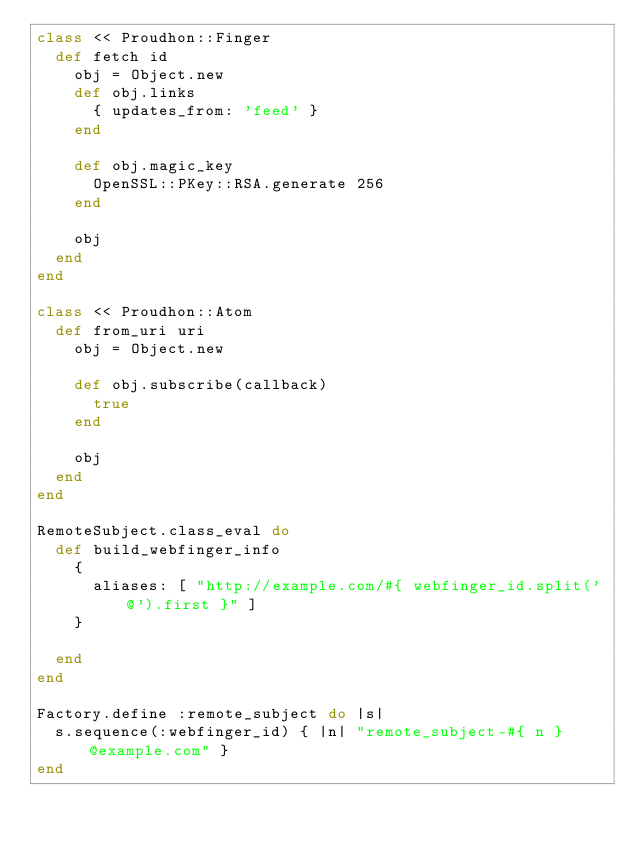Convert code to text. <code><loc_0><loc_0><loc_500><loc_500><_Ruby_>class << Proudhon::Finger
  def fetch id
    obj = Object.new
    def obj.links
      { updates_from: 'feed' }
    end

    def obj.magic_key
      OpenSSL::PKey::RSA.generate 256
    end

    obj
  end
end

class << Proudhon::Atom
  def from_uri uri
    obj = Object.new

    def obj.subscribe(callback)
      true
    end

    obj
  end
end

RemoteSubject.class_eval do
  def build_webfinger_info
    {
      aliases: [ "http://example.com/#{ webfinger_id.split('@').first }" ]
    }

  end
end

Factory.define :remote_subject do |s|
  s.sequence(:webfinger_id) { |n| "remote_subject-#{ n }@example.com" }
end
</code> 